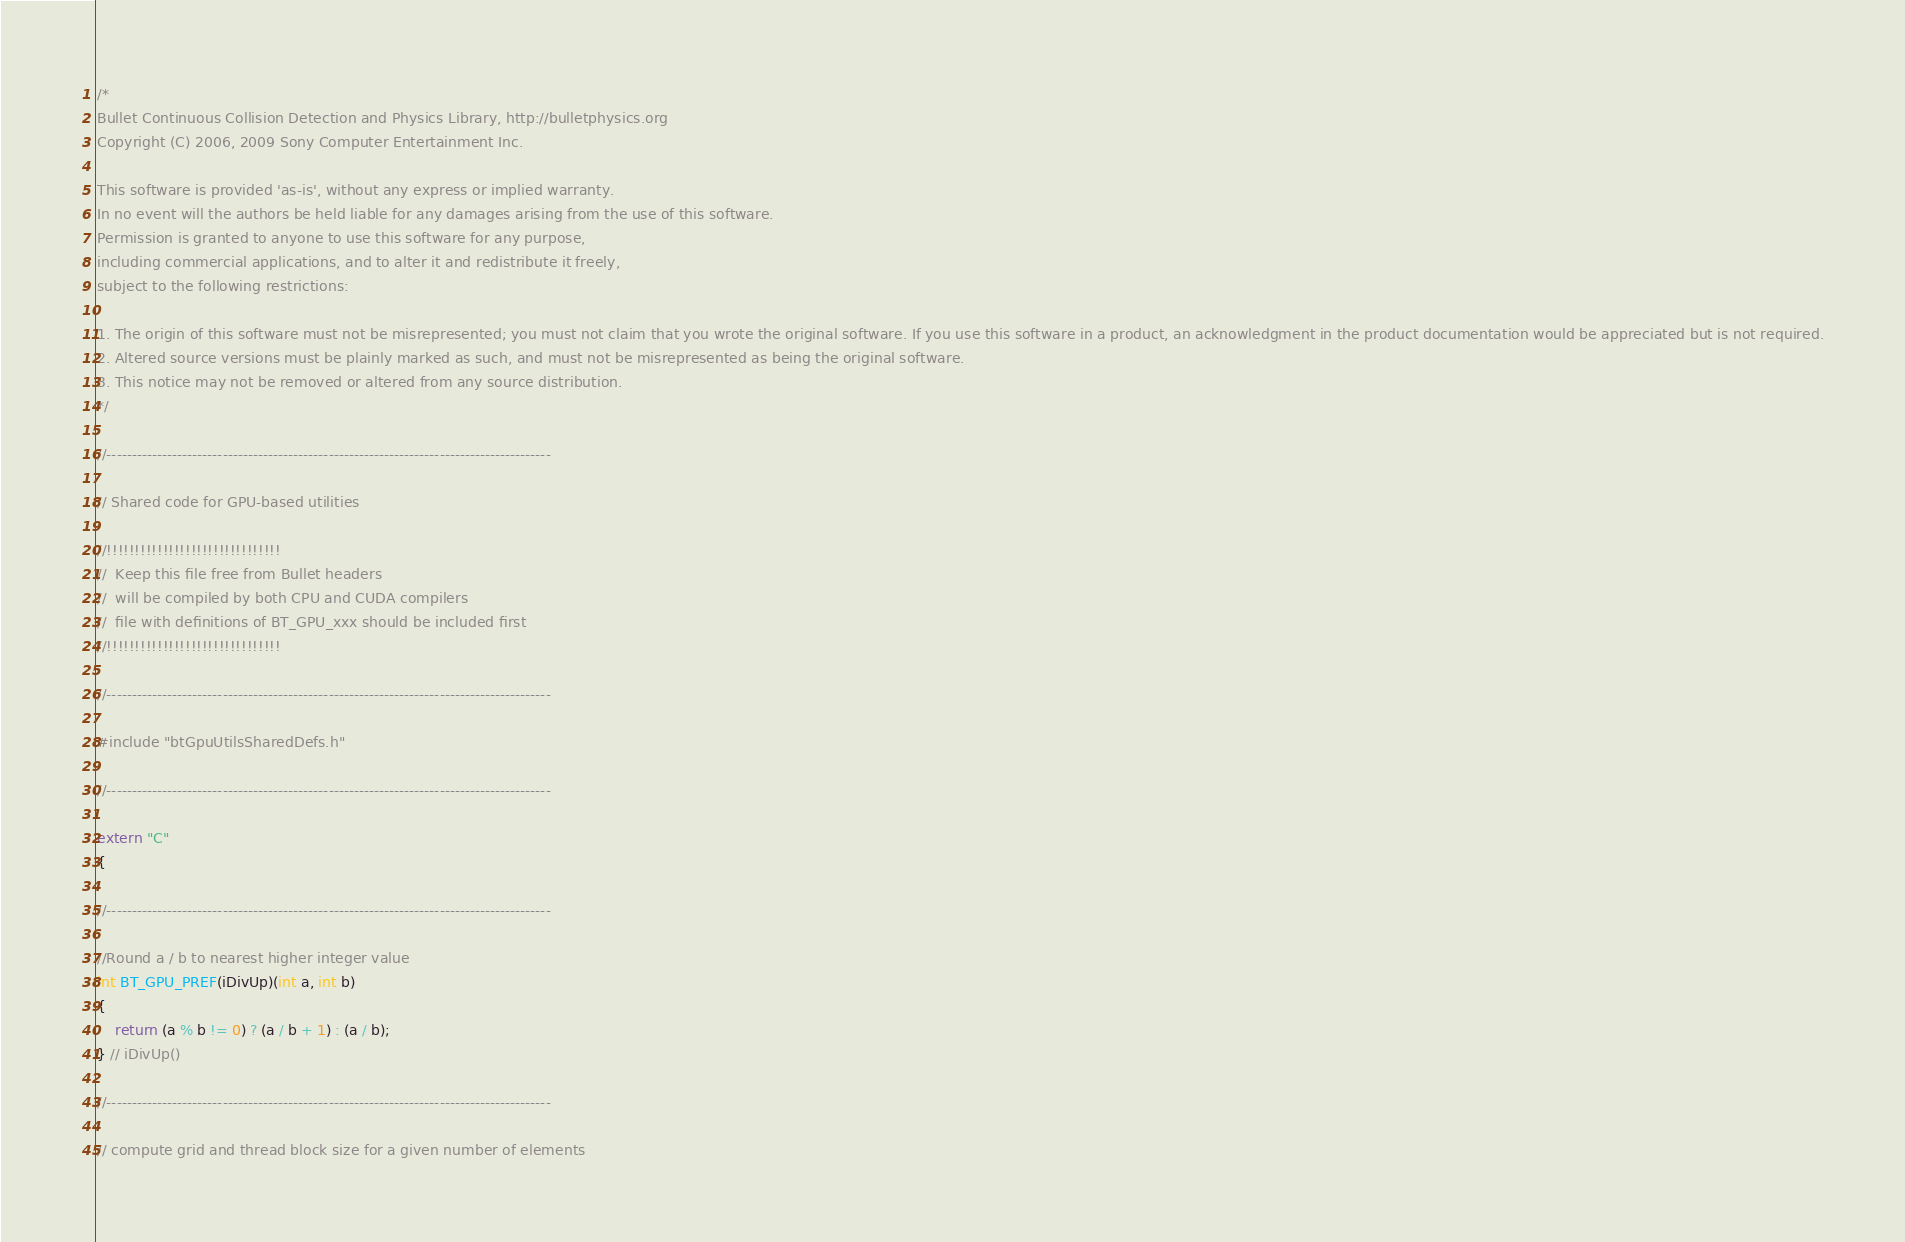<code> <loc_0><loc_0><loc_500><loc_500><_C_>/*
Bullet Continuous Collision Detection and Physics Library, http://bulletphysics.org
Copyright (C) 2006, 2009 Sony Computer Entertainment Inc. 

This software is provided 'as-is', without any express or implied warranty.
In no event will the authors be held liable for any damages arising from the use of this software.
Permission is granted to anyone to use this software for any purpose, 
including commercial applications, and to alter it and redistribute it freely, 
subject to the following restrictions:

1. The origin of this software must not be misrepresented; you must not claim that you wrote the original software. If you use this software in a product, an acknowledgment in the product documentation would be appreciated but is not required.
2. Altered source versions must be plainly marked as such, and must not be misrepresented as being the original software.
3. This notice may not be removed or altered from any source distribution.
*/

//----------------------------------------------------------------------------------------

// Shared code for GPU-based utilities

//!!!!!!!!!!!!!!!!!!!!!!!!!!!!!!!
//  Keep this file free from Bullet headers
//  will be compiled by both CPU and CUDA compilers
//	file with definitions of BT_GPU_xxx should be included first
//!!!!!!!!!!!!!!!!!!!!!!!!!!!!!!!

//----------------------------------------------------------------------------------------

#include "btGpuUtilsSharedDefs.h"

//----------------------------------------------------------------------------------------

extern "C"
{

//----------------------------------------------------------------------------------------

//Round a / b to nearest higher integer value
int BT_GPU_PREF(iDivUp)(int a, int b)
{
    return (a % b != 0) ? (a / b + 1) : (a / b);
} // iDivUp()

//----------------------------------------------------------------------------------------

// compute grid and thread block size for a given number of elements</code> 